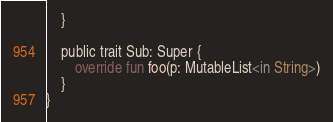Convert code to text. <code><loc_0><loc_0><loc_500><loc_500><_Kotlin_>    }

    public trait Sub: Super {
        override fun foo(p: MutableList<in String>)
    }
}
</code> 